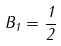Convert formula to latex. <formula><loc_0><loc_0><loc_500><loc_500>B _ { 1 } = \frac { 1 } { 2 }</formula> 